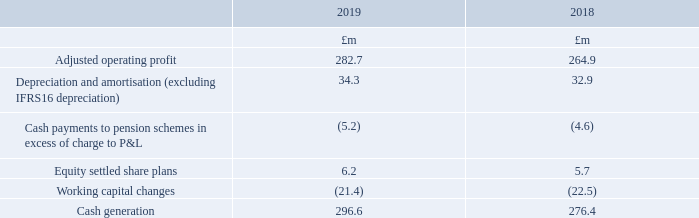2 Alternative performance measures continued
Cash generation
Cash generation is one of the Group’s key performance indicators used by the Board to monitor the performance of the Group and measure the successful implementation of our strategy. It is one of three financial measures on which Executive Directors’ variable remuneration is based.
Cash generation is adjusted operating profit after adding back depreciation and amortisation (excluding IFRS 16 depreciation), less cash payments to pension schemes in excess of the charge to operating profit, equity settled share plans and working capital changes.
How is cash generation data used by the Board? Key performance indicators used by the board to monitor the performance of the group and measure the successful implementation of our strategy. it is one of three financial measures on which executive directors’ variable remuneration is based. How is cash generation calculated? Adjusted operating profit after adding back depreciation and amortisation (excluding ifrs 16 depreciation), less cash payments to pension schemes in excess of the charge to operating profit, equity settled share plans and working capital changes. For which years was the cash generation calculated in? 2019, 2018. In which year was the amount of adjusted operating profit larger? 282.7>264.9
Answer: 2019. What was the change in equity settled share plans in 2019 from 2018?
Answer scale should be: million. 6.2-5.7
Answer: 0.5. What was the percentage change in equity settled share plans in 2019 from 2018?
Answer scale should be: percent. (6.2-5.7)/5.7
Answer: 8.77. 